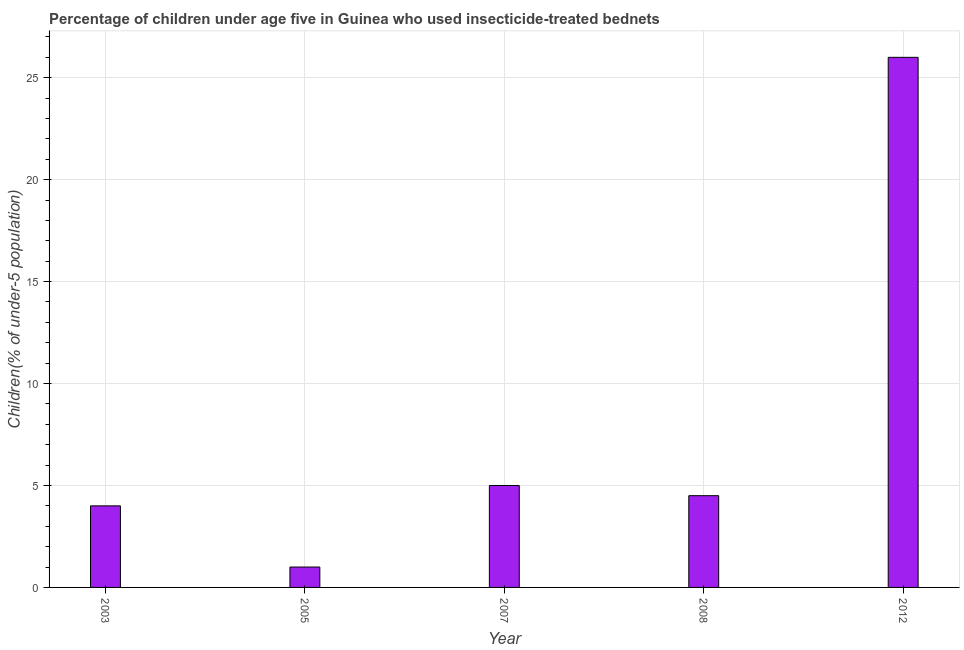Does the graph contain any zero values?
Give a very brief answer. No. What is the title of the graph?
Your answer should be very brief. Percentage of children under age five in Guinea who used insecticide-treated bednets. What is the label or title of the X-axis?
Offer a terse response. Year. What is the label or title of the Y-axis?
Your response must be concise. Children(% of under-5 population). What is the percentage of children who use of insecticide-treated bed nets in 2005?
Your answer should be very brief. 1. In which year was the percentage of children who use of insecticide-treated bed nets maximum?
Offer a very short reply. 2012. What is the sum of the percentage of children who use of insecticide-treated bed nets?
Keep it short and to the point. 40.5. What is the difference between the percentage of children who use of insecticide-treated bed nets in 2003 and 2005?
Give a very brief answer. 3. What is the average percentage of children who use of insecticide-treated bed nets per year?
Provide a succinct answer. 8.1. In how many years, is the percentage of children who use of insecticide-treated bed nets greater than 13 %?
Your answer should be compact. 1. What is the ratio of the percentage of children who use of insecticide-treated bed nets in 2003 to that in 2012?
Give a very brief answer. 0.15. Is the difference between the percentage of children who use of insecticide-treated bed nets in 2008 and 2012 greater than the difference between any two years?
Ensure brevity in your answer.  No. What is the difference between the highest and the second highest percentage of children who use of insecticide-treated bed nets?
Ensure brevity in your answer.  21. Is the sum of the percentage of children who use of insecticide-treated bed nets in 2007 and 2008 greater than the maximum percentage of children who use of insecticide-treated bed nets across all years?
Keep it short and to the point. No. What is the difference between the highest and the lowest percentage of children who use of insecticide-treated bed nets?
Your answer should be compact. 25. What is the difference between two consecutive major ticks on the Y-axis?
Offer a very short reply. 5. Are the values on the major ticks of Y-axis written in scientific E-notation?
Provide a succinct answer. No. What is the Children(% of under-5 population) in 2003?
Your response must be concise. 4. What is the Children(% of under-5 population) in 2005?
Make the answer very short. 1. What is the Children(% of under-5 population) of 2012?
Your response must be concise. 26. What is the difference between the Children(% of under-5 population) in 2003 and 2008?
Your response must be concise. -0.5. What is the difference between the Children(% of under-5 population) in 2003 and 2012?
Offer a terse response. -22. What is the difference between the Children(% of under-5 population) in 2005 and 2007?
Your response must be concise. -4. What is the difference between the Children(% of under-5 population) in 2007 and 2012?
Your response must be concise. -21. What is the difference between the Children(% of under-5 population) in 2008 and 2012?
Keep it short and to the point. -21.5. What is the ratio of the Children(% of under-5 population) in 2003 to that in 2007?
Keep it short and to the point. 0.8. What is the ratio of the Children(% of under-5 population) in 2003 to that in 2008?
Make the answer very short. 0.89. What is the ratio of the Children(% of under-5 population) in 2003 to that in 2012?
Your answer should be compact. 0.15. What is the ratio of the Children(% of under-5 population) in 2005 to that in 2008?
Keep it short and to the point. 0.22. What is the ratio of the Children(% of under-5 population) in 2005 to that in 2012?
Ensure brevity in your answer.  0.04. What is the ratio of the Children(% of under-5 population) in 2007 to that in 2008?
Give a very brief answer. 1.11. What is the ratio of the Children(% of under-5 population) in 2007 to that in 2012?
Offer a terse response. 0.19. What is the ratio of the Children(% of under-5 population) in 2008 to that in 2012?
Give a very brief answer. 0.17. 